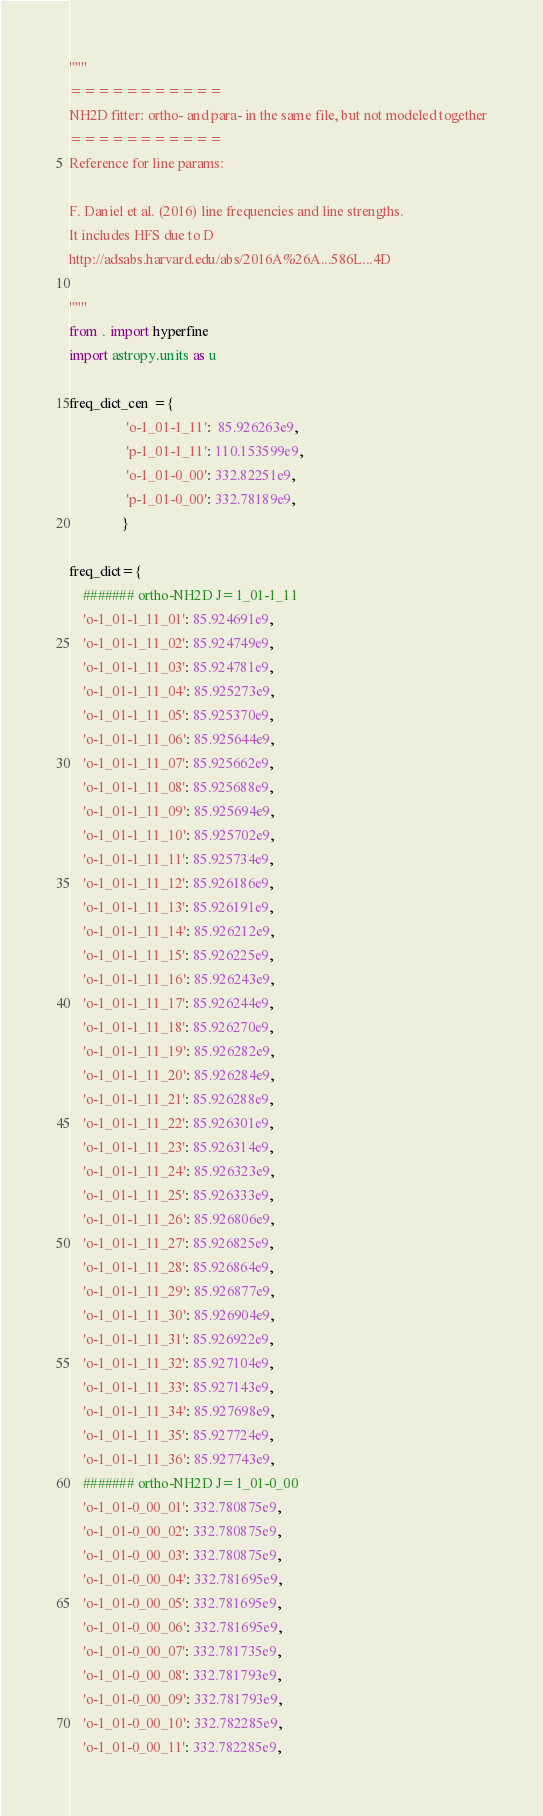<code> <loc_0><loc_0><loc_500><loc_500><_Python_>"""
===========
NH2D fitter: ortho- and para- in the same file, but not modeled together
===========
Reference for line params:

F. Daniel et al. (2016) line frequencies and line strengths.
It includes HFS due to D
http://adsabs.harvard.edu/abs/2016A%26A...586L...4D

"""
from . import hyperfine
import astropy.units as u

freq_dict_cen ={
                'o-1_01-1_11':  85.926263e9,
                'p-1_01-1_11': 110.153599e9,
                'o-1_01-0_00': 332.82251e9,
                'p-1_01-0_00': 332.78189e9,
               }

freq_dict={
    ####### ortho-NH2D J=1_01-1_11
    'o-1_01-1_11_01': 85.924691e9,
    'o-1_01-1_11_02': 85.924749e9,
    'o-1_01-1_11_03': 85.924781e9,
    'o-1_01-1_11_04': 85.925273e9,
    'o-1_01-1_11_05': 85.925370e9,
    'o-1_01-1_11_06': 85.925644e9,
    'o-1_01-1_11_07': 85.925662e9,
    'o-1_01-1_11_08': 85.925688e9,
    'o-1_01-1_11_09': 85.925694e9,
    'o-1_01-1_11_10': 85.925702e9,
    'o-1_01-1_11_11': 85.925734e9,
    'o-1_01-1_11_12': 85.926186e9,
    'o-1_01-1_11_13': 85.926191e9,
    'o-1_01-1_11_14': 85.926212e9,
    'o-1_01-1_11_15': 85.926225e9,
    'o-1_01-1_11_16': 85.926243e9,
    'o-1_01-1_11_17': 85.926244e9,
    'o-1_01-1_11_18': 85.926270e9,
    'o-1_01-1_11_19': 85.926282e9,
    'o-1_01-1_11_20': 85.926284e9,
    'o-1_01-1_11_21': 85.926288e9,
    'o-1_01-1_11_22': 85.926301e9,
    'o-1_01-1_11_23': 85.926314e9,
    'o-1_01-1_11_24': 85.926323e9,
    'o-1_01-1_11_25': 85.926333e9,
    'o-1_01-1_11_26': 85.926806e9,
    'o-1_01-1_11_27': 85.926825e9,
    'o-1_01-1_11_28': 85.926864e9,
    'o-1_01-1_11_29': 85.926877e9,
    'o-1_01-1_11_30': 85.926904e9,
    'o-1_01-1_11_31': 85.926922e9,
    'o-1_01-1_11_32': 85.927104e9,
    'o-1_01-1_11_33': 85.927143e9,
    'o-1_01-1_11_34': 85.927698e9,
    'o-1_01-1_11_35': 85.927724e9,
    'o-1_01-1_11_36': 85.927743e9,
    ####### ortho-NH2D J=1_01-0_00
    'o-1_01-0_00_01': 332.780875e9,
    'o-1_01-0_00_02': 332.780875e9,
    'o-1_01-0_00_03': 332.780875e9,
    'o-1_01-0_00_04': 332.781695e9,
    'o-1_01-0_00_05': 332.781695e9,
    'o-1_01-0_00_06': 332.781695e9,
    'o-1_01-0_00_07': 332.781735e9,
    'o-1_01-0_00_08': 332.781793e9,
    'o-1_01-0_00_09': 332.781793e9,
    'o-1_01-0_00_10': 332.782285e9,
    'o-1_01-0_00_11': 332.782285e9,</code> 